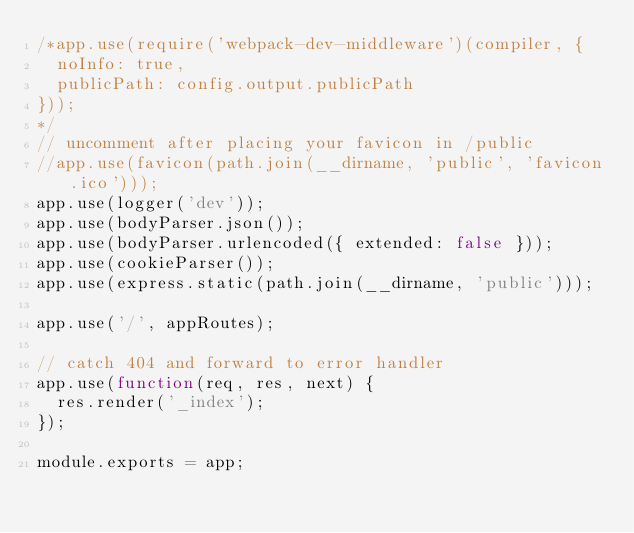Convert code to text. <code><loc_0><loc_0><loc_500><loc_500><_JavaScript_>/*app.use(require('webpack-dev-middleware')(compiler, {
  noInfo: true,
  publicPath: config.output.publicPath
}));
*/
// uncomment after placing your favicon in /public
//app.use(favicon(path.join(__dirname, 'public', 'favicon.ico')));
app.use(logger('dev'));
app.use(bodyParser.json());
app.use(bodyParser.urlencoded({ extended: false }));
app.use(cookieParser());
app.use(express.static(path.join(__dirname, 'public')));

app.use('/', appRoutes);

// catch 404 and forward to error handler
app.use(function(req, res, next) {
  res.render('_index');
});

module.exports = app;
</code> 